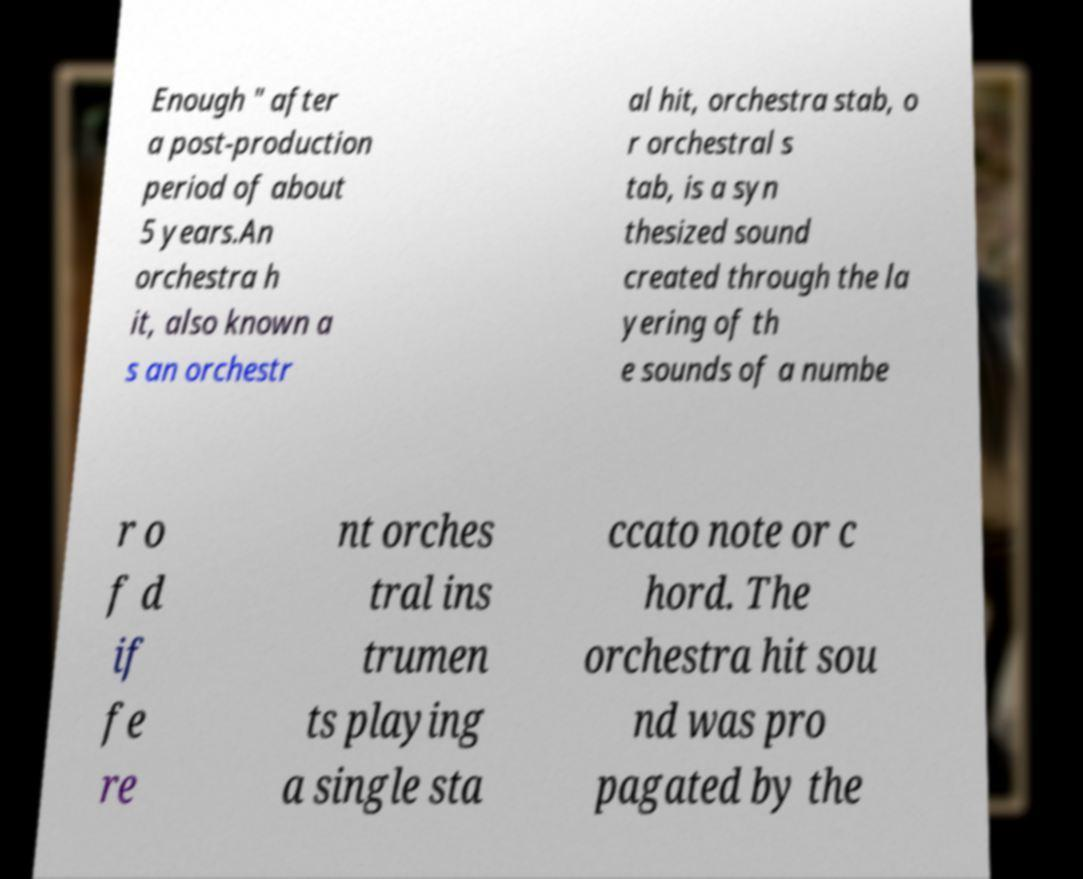Could you extract and type out the text from this image? Enough " after a post-production period of about 5 years.An orchestra h it, also known a s an orchestr al hit, orchestra stab, o r orchestral s tab, is a syn thesized sound created through the la yering of th e sounds of a numbe r o f d if fe re nt orches tral ins trumen ts playing a single sta ccato note or c hord. The orchestra hit sou nd was pro pagated by the 